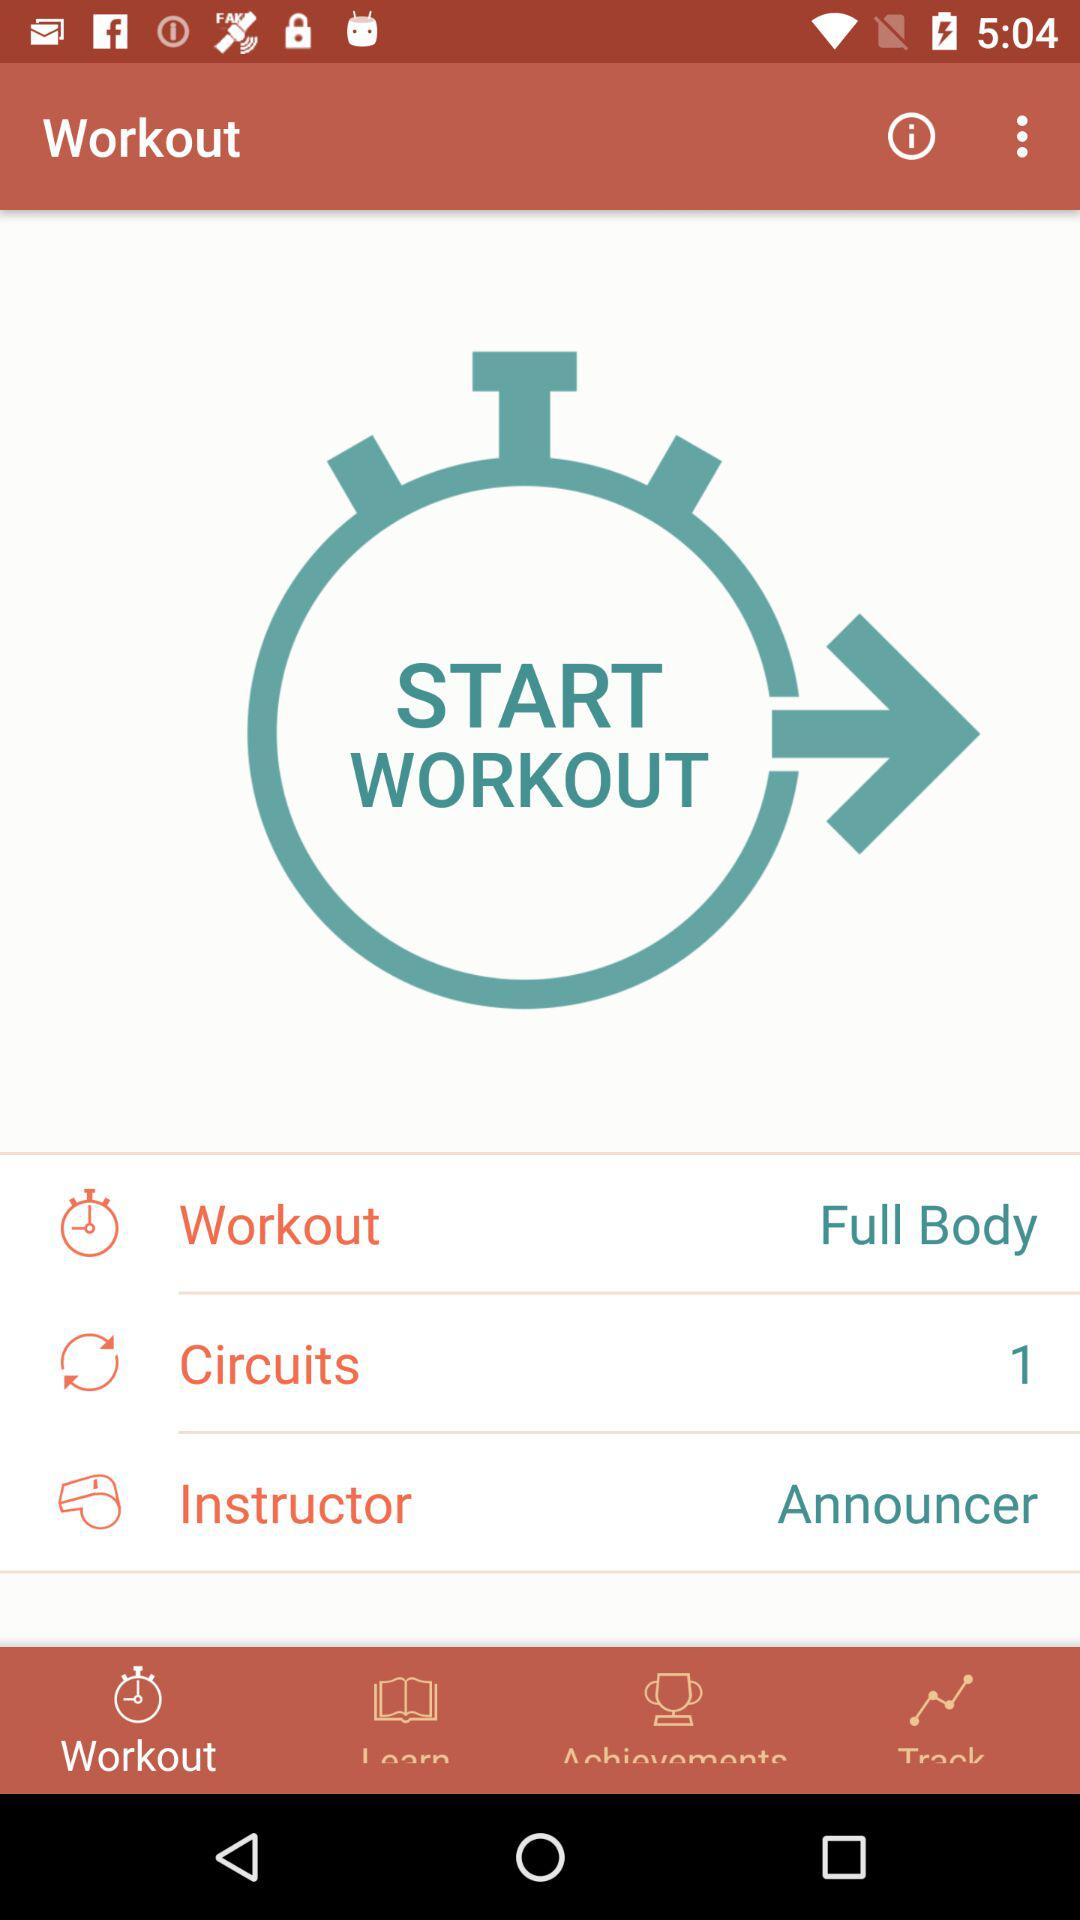What is the type of workout? It is a full-body workout. 